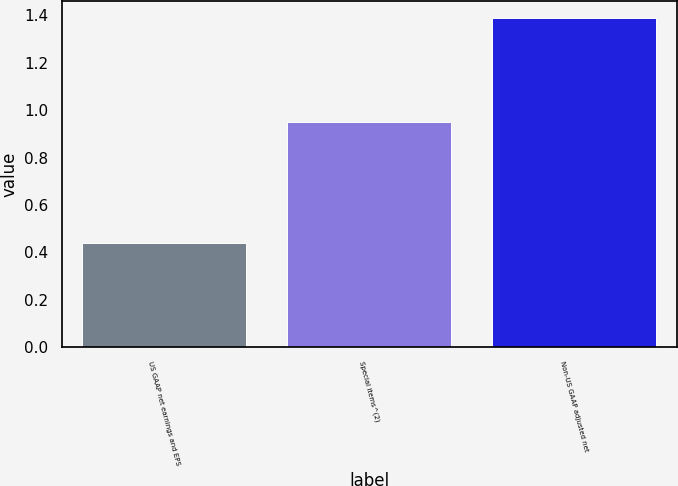Convert chart to OTSL. <chart><loc_0><loc_0><loc_500><loc_500><bar_chart><fcel>US GAAP net earnings and EPS<fcel>Special items^(2)<fcel>Non-US GAAP adjusted net<nl><fcel>0.44<fcel>0.95<fcel>1.39<nl></chart> 